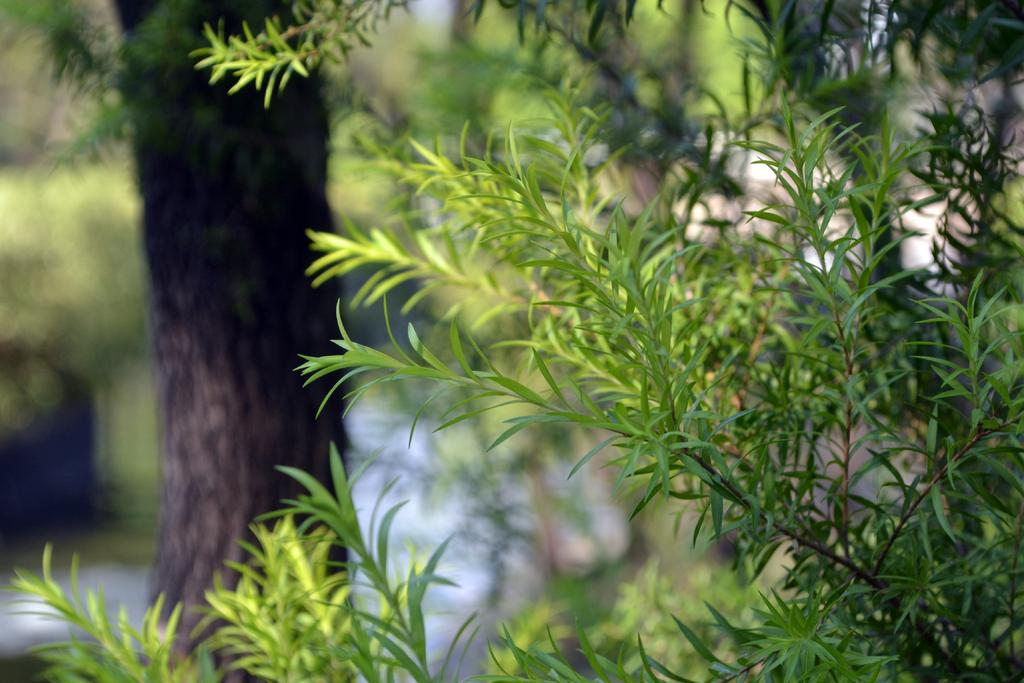What type of living organisms can be seen in the image? Plants and a tree are visible in the image. Can you describe the background of the image? The background of the image is blurred. What type of pleasure can be seen on the boy's face in the image? There is no boy present in the image, so it is not possible to determine any pleasure on his face. 